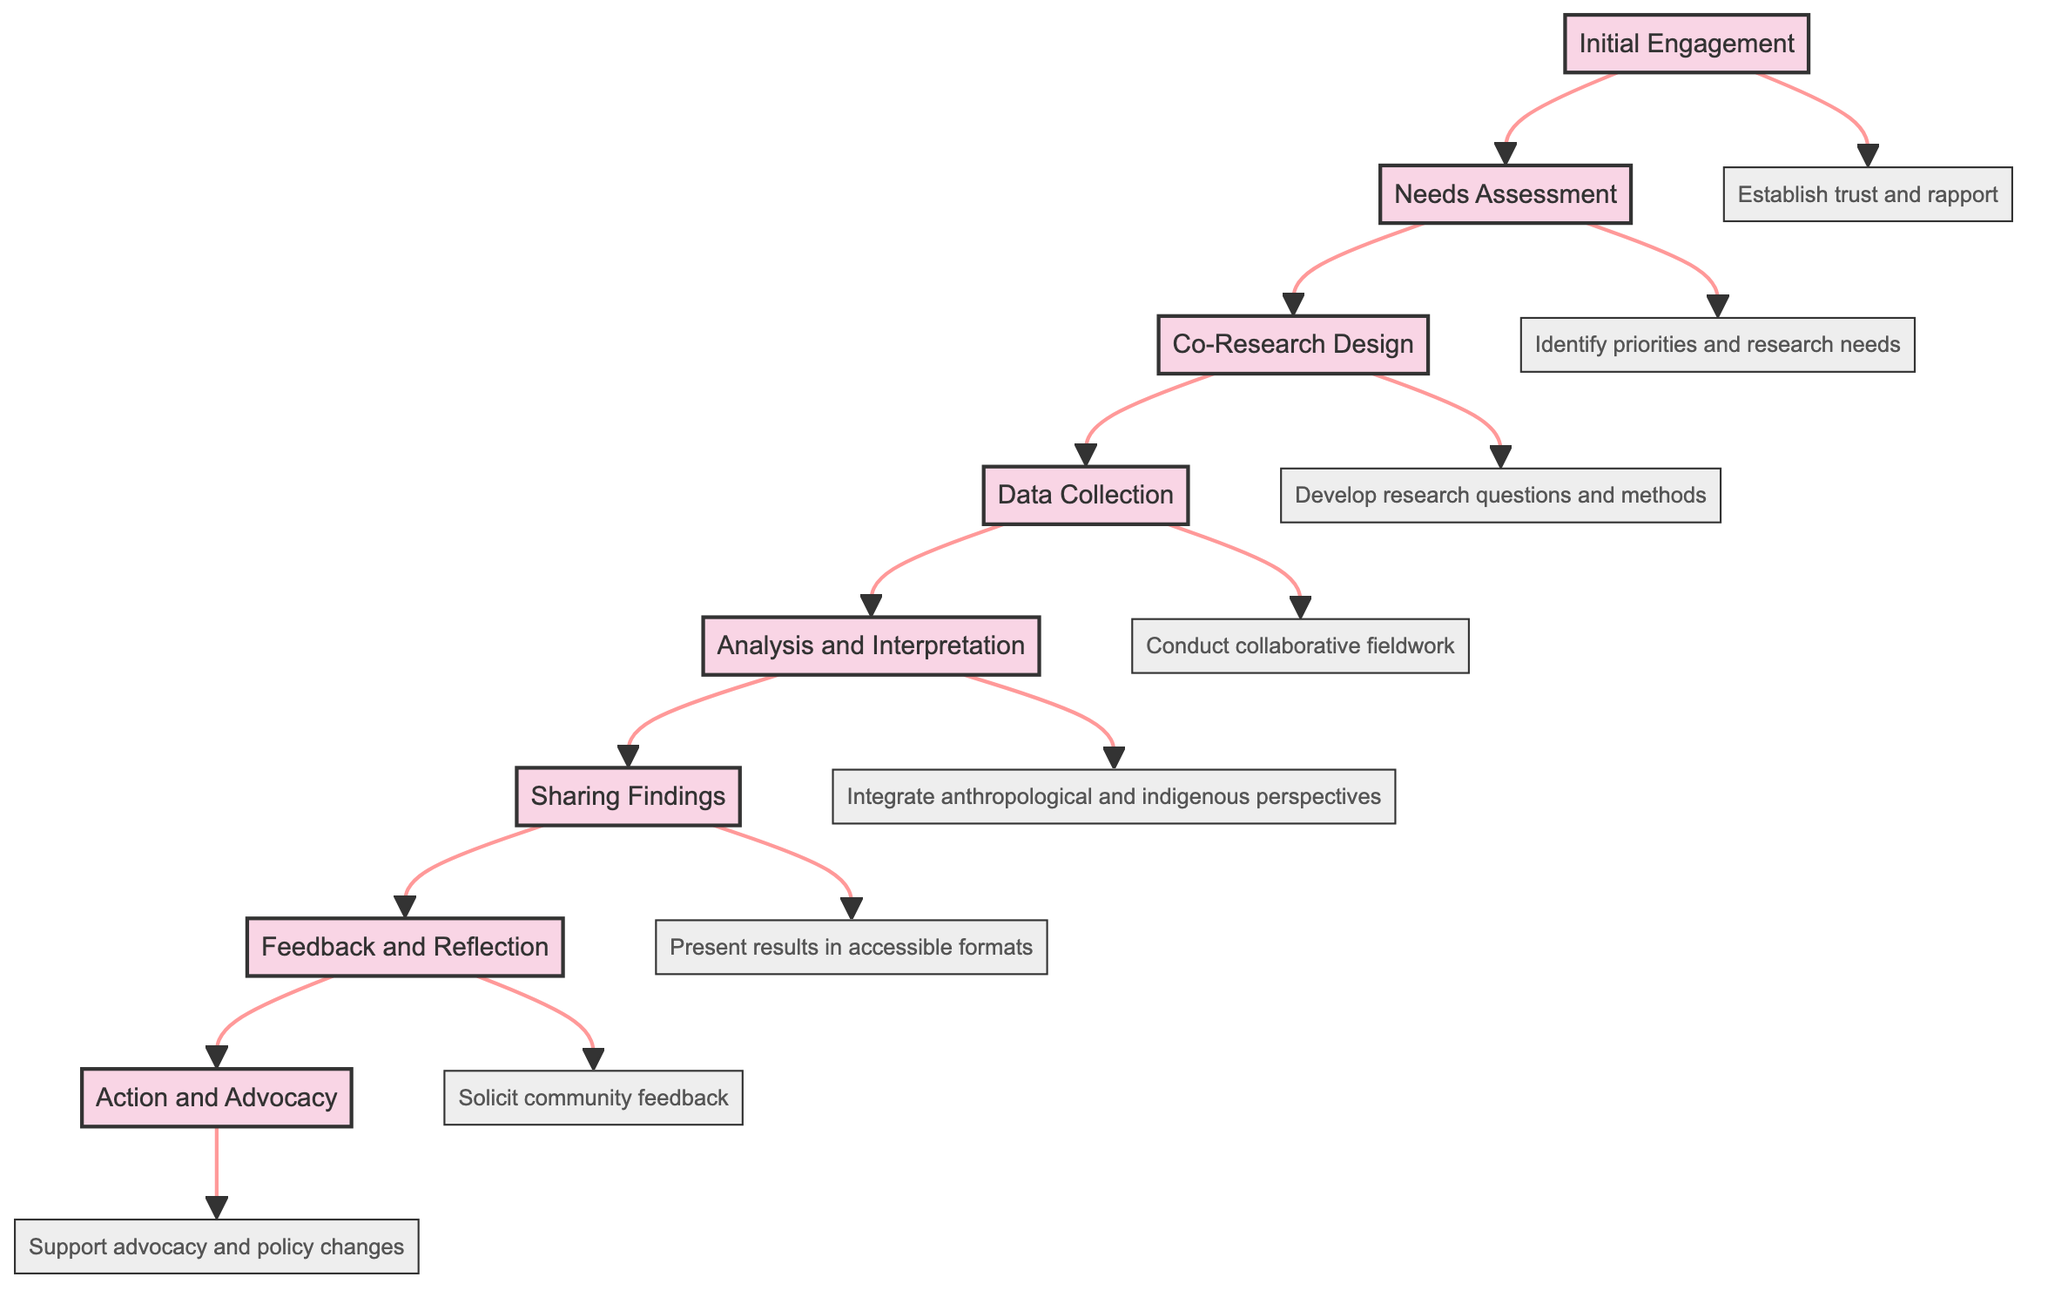What is the final stage of the collaborative project? The flowchart leads sequentially from 'Initial Engagement' to 'Action and Advocacy'. The last node is 'Action and Advocacy', making it the final stage of the collaborative project.
Answer: Action and Advocacy Which stage comes after 'Data Collection'? Following the flow of the diagram, 'Data Collection' is connected to 'Analysis and Interpretation', indicating that 'Analysis and Interpretation' is the next stage after 'Data Collection'.
Answer: Analysis and Interpretation How many total stages are in the flowchart? By counting the distinct stages listed in the flowchart, there are eight individual stages outlined from 'Initial Engagement' to 'Action and Advocacy'.
Answer: Eight What activity is involved in the 'Co-Research Design' stage? The description linked to 'Co-Research Design' states that this stage involves the collaborative development of research questions and methods, emphasizing its focus on respecting indigenous knowledge systems.
Answer: Develop research questions and methods What is the main purpose of the 'Sharing Findings' stage? The diagram shows that in the 'Sharing Findings' stage, the results need to be presented to the community in accessible formats, focusing on prioritizing indigenous voices and interpretations.
Answer: Present results in accessible formats Which stages involve collaborative efforts with indigenous community members? The stages include 'Initial Engagement', 'Needs Assessment', 'Data Collection', 'Analysis and Interpretation', 'Sharing Findings', and 'Feedback and Reflection', all of which emphasize collaboration with indigenous community members.
Answer: Initial Engagement, Needs Assessment, Data Collection, Analysis and Interpretation, Sharing Findings, Feedback and Reflection What is the first activity in the collaborative process according to the flowchart? The flowchart starts with the 'Initial Engagement' stage, where establishing trust and rapport with the indigenous community occurs, marking it as the first activity in the collaborative process.
Answer: Establish trust and rapport What is intended by the 'Feedback and Reflection' stage? The 'Feedback and Reflection' stage aims to solicit community feedback on the findings and the research process, indicating a desire for ongoing dialogue and learning, thereby ensuring community involvement.
Answer: Solicit community feedback 